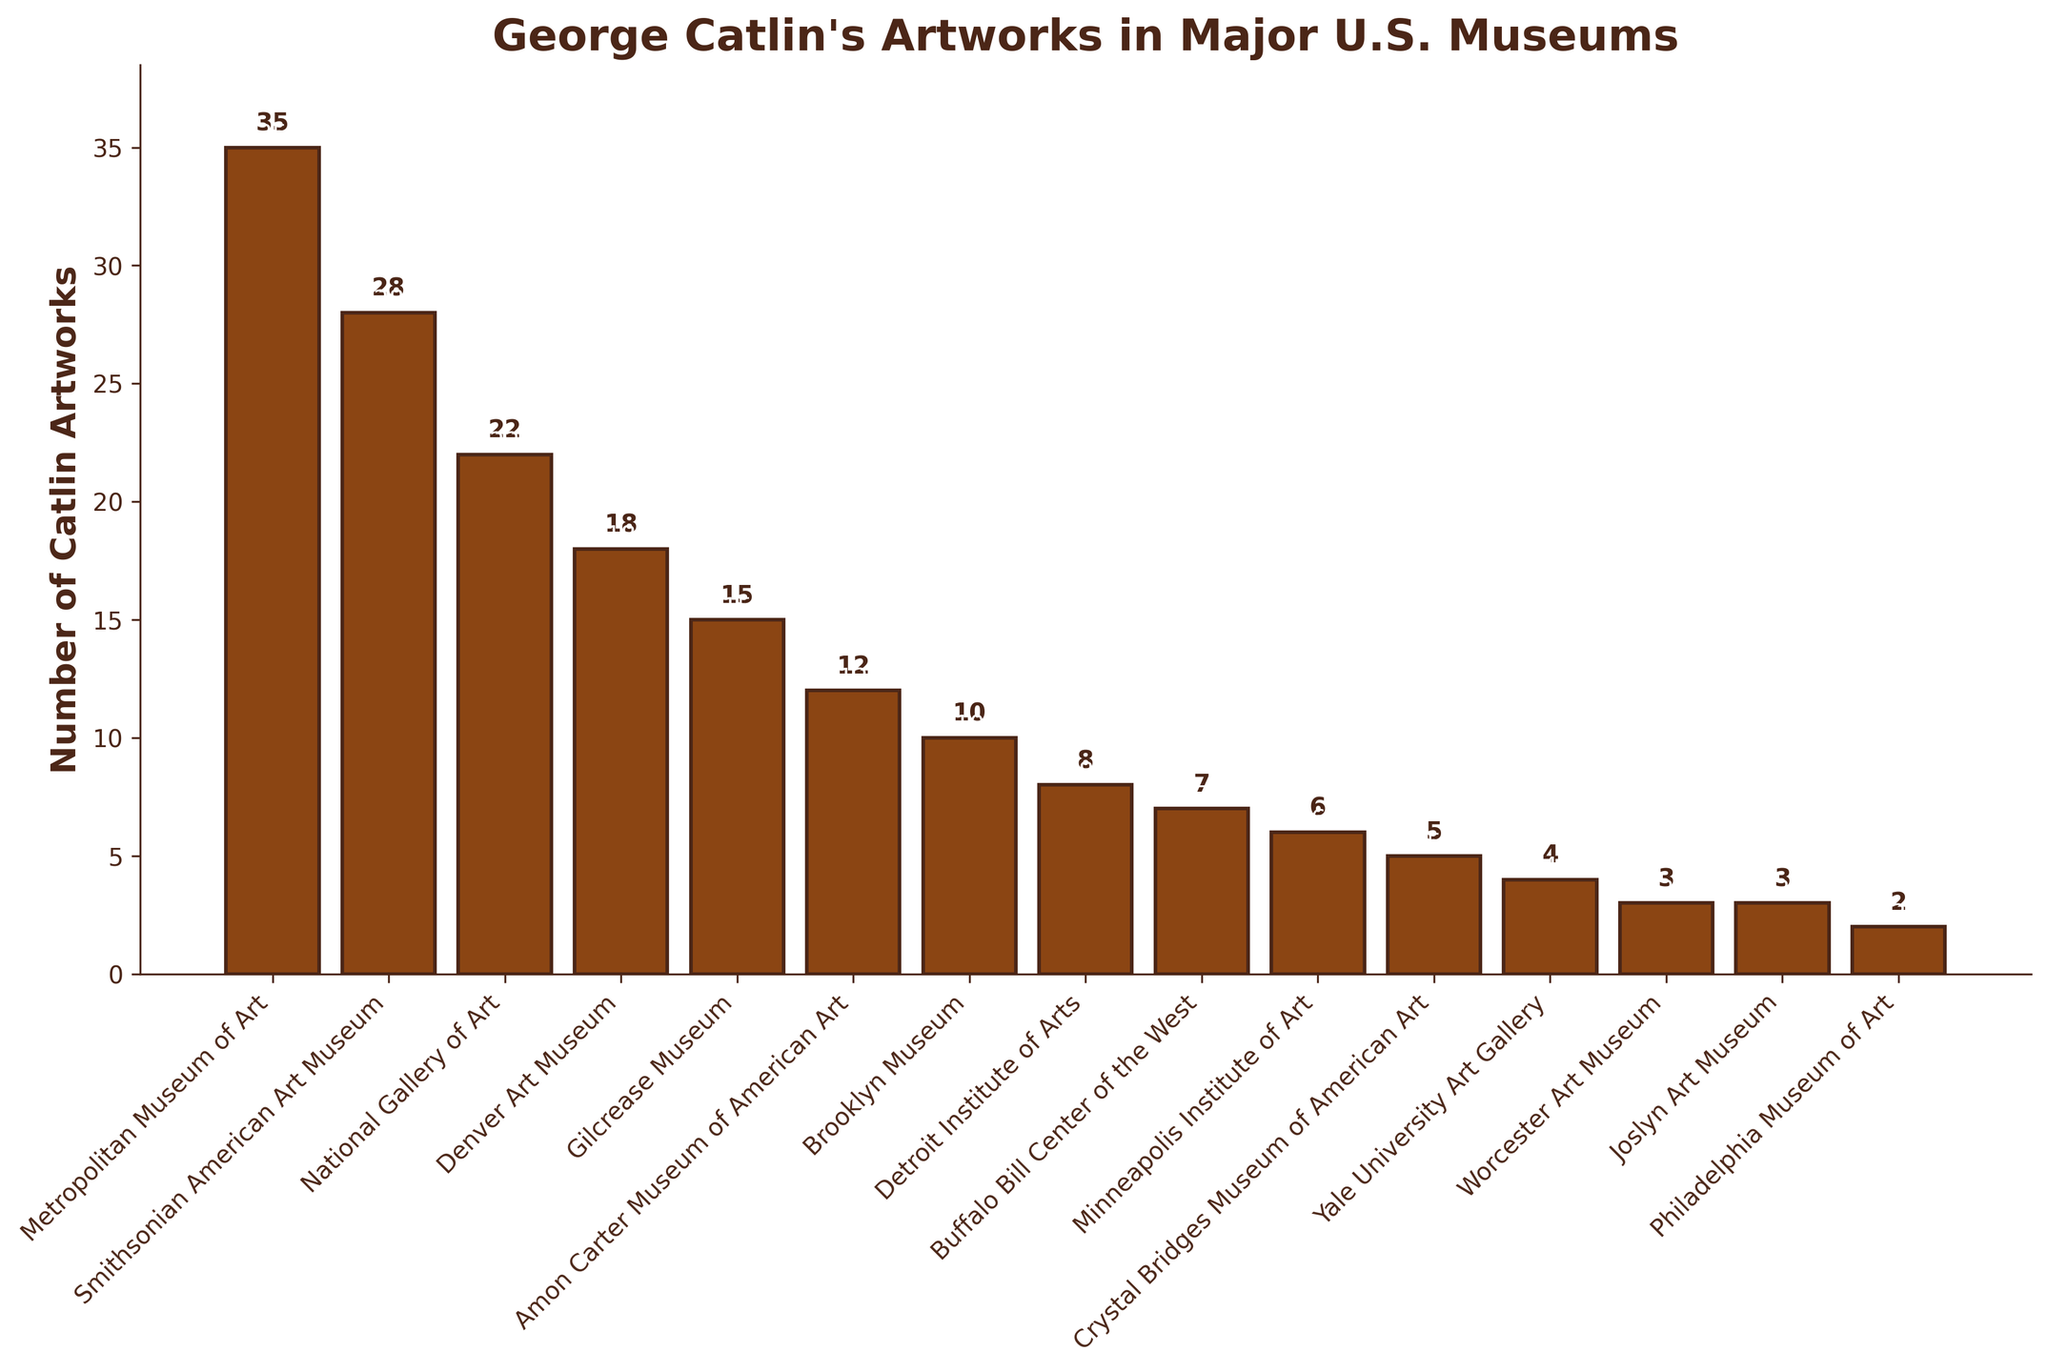What is the total number of George Catlin's artworks displayed in the Metropolitan Museum of Art and the Smithsonian American Art Museum? Add the number of artworks from the Metropolitan Museum of Art (35) and the Smithsonian American Art Museum (28). 35 + 28 = 63
Answer: 63 Which museum has the fewest George Catlin artworks, and how many are there? Look for the smallest value on the vertical axis and its corresponding museum. The Philadelphia Museum of Art has the fewest, with 2 artworks displayed.
Answer: Philadelphia Museum of Art, 2 What is the difference in the number of George Catlin's artworks between the National Gallery of Art and the Crystal Bridges Museum of American Art? Subtract the number of artworks in the Crystal Bridges Museum of American Art (5) from the National Gallery of Art (22). 22 - 5 = 17
Answer: 17 How many more George Catlin artworks does the Metropolitan Museum of Art have compared to the Brooklyn Museum? Subtract the number of artworks in the Brooklyn Museum (10) from the Metropolitan Museum of Art (35). 35 - 10 = 25
Answer: 25 Which three museums have the highest number of George Catlin's artworks, and what are their respective counts? Identify the three highest values and their corresponding museums. They are the Metropolitan Museum of Art (35), Smithsonian American Art Museum (28), and the National Gallery of Art (22).
Answer: Metropolitan Museum of Art (35), Smithsonian American Art Museum (28), National Gallery of Art (22) What is the average number of George Catlin's artworks displayed across all the museums listed? Sum all the values of the artworks and divide by the number of museums (15). (35+28+22+18+15+12+10+8+7+6+5+4+3+3+2) = 178, then 178 ÷ 15 ≈ 11.87
Answer: 11.87 Are there more George Catlin artworks in the Denver Art Museum or the Amon Carter Museum of American Art, and by how many? Compare the values for the Denver Art Museum (18) and the Amon Carter Museum of American Art (12). Subtract the smaller number from the larger. 18 - 12 = 6
Answer: Denver Art Museum, by 6 What is the combined total of George Catlin's artworks in the Gilcrease Museum, Buffalo Bill Center of the West, and the Yale University Art Gallery? Sum the number of artworks in the Gilcrease Museum (15), Buffalo Bill Center of the West (7), and Yale University Art Gallery (4). 15 + 7 + 4 = 26
Answer: 26 Which museum has a slightly higher number of George Catlin's artworks than the Detroit Institute of Arts, and what are their respective counts? Identify the museum with the count just above the Detroit Institute of Arts (8). The Brooklyn Museum has a slightly higher count with 10.
Answer: Brooklyn Museum (10), Detroit Institute of Arts (8) Visually, which museum's bar is the tallest, and which one's is the shortest? The tallest bar corresponds to the Metropolitan Museum of Art, and the shortest corresponds to the Philadelphia Museum of Art.
Answer: Tallest: Metropolitan Museum of Art, Shortest: Philadelphia Museum of Art 